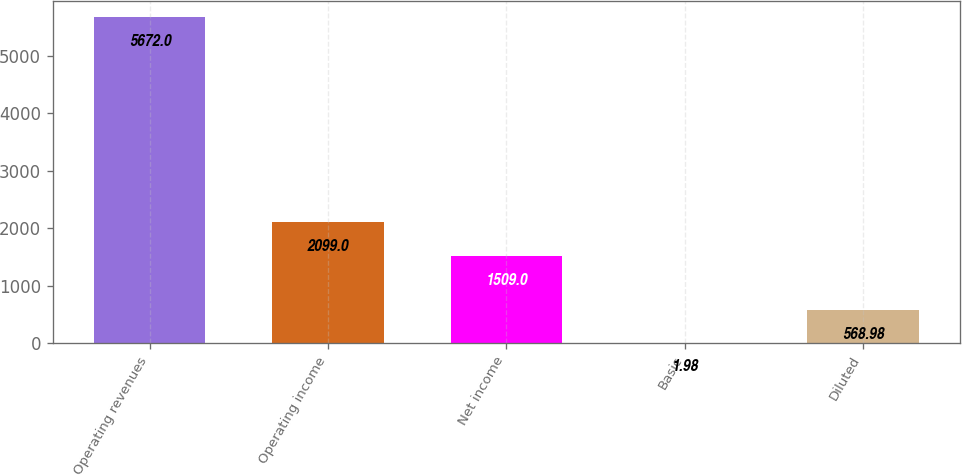Convert chart. <chart><loc_0><loc_0><loc_500><loc_500><bar_chart><fcel>Operating revenues<fcel>Operating income<fcel>Net income<fcel>Basic<fcel>Diluted<nl><fcel>5672<fcel>2099<fcel>1509<fcel>1.98<fcel>568.98<nl></chart> 